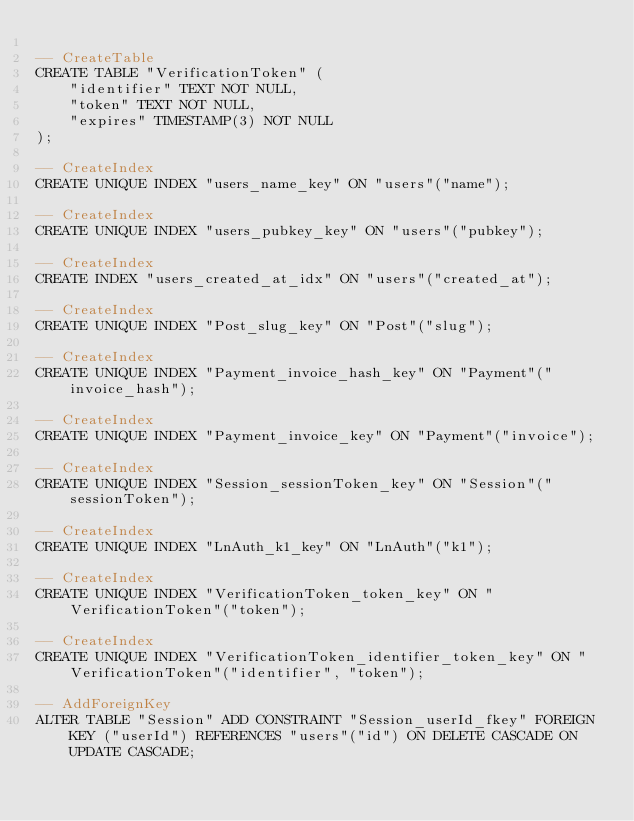Convert code to text. <code><loc_0><loc_0><loc_500><loc_500><_SQL_>
-- CreateTable
CREATE TABLE "VerificationToken" (
    "identifier" TEXT NOT NULL,
    "token" TEXT NOT NULL,
    "expires" TIMESTAMP(3) NOT NULL
);

-- CreateIndex
CREATE UNIQUE INDEX "users_name_key" ON "users"("name");

-- CreateIndex
CREATE UNIQUE INDEX "users_pubkey_key" ON "users"("pubkey");

-- CreateIndex
CREATE INDEX "users_created_at_idx" ON "users"("created_at");

-- CreateIndex
CREATE UNIQUE INDEX "Post_slug_key" ON "Post"("slug");

-- CreateIndex
CREATE UNIQUE INDEX "Payment_invoice_hash_key" ON "Payment"("invoice_hash");

-- CreateIndex
CREATE UNIQUE INDEX "Payment_invoice_key" ON "Payment"("invoice");

-- CreateIndex
CREATE UNIQUE INDEX "Session_sessionToken_key" ON "Session"("sessionToken");

-- CreateIndex
CREATE UNIQUE INDEX "LnAuth_k1_key" ON "LnAuth"("k1");

-- CreateIndex
CREATE UNIQUE INDEX "VerificationToken_token_key" ON "VerificationToken"("token");

-- CreateIndex
CREATE UNIQUE INDEX "VerificationToken_identifier_token_key" ON "VerificationToken"("identifier", "token");

-- AddForeignKey
ALTER TABLE "Session" ADD CONSTRAINT "Session_userId_fkey" FOREIGN KEY ("userId") REFERENCES "users"("id") ON DELETE CASCADE ON UPDATE CASCADE;
</code> 